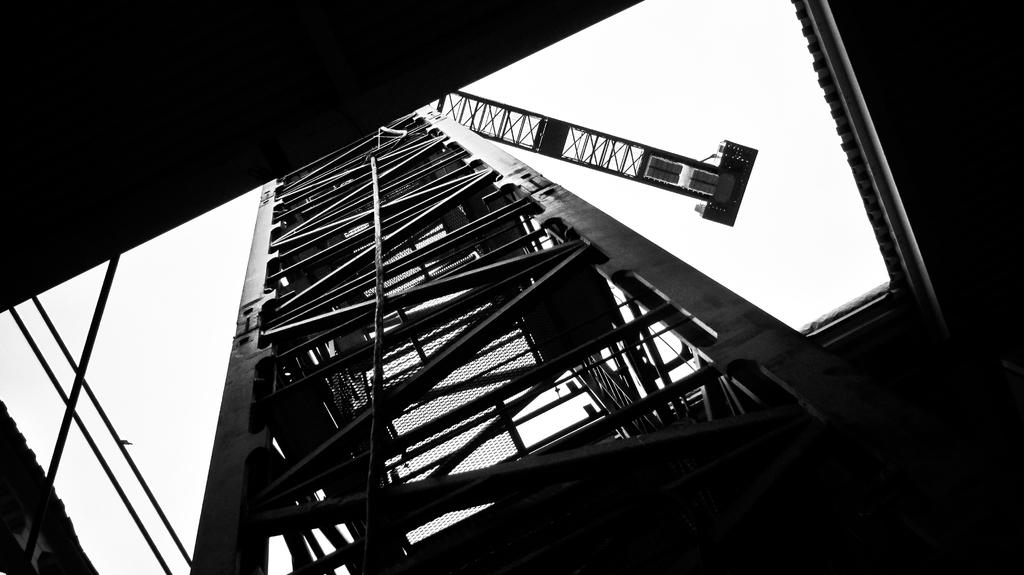What type of structure is present in the image? There is a building in the image. What material can be seen in the image besides the building? Metal rods are visible in the image. What part of the natural environment is visible in the image? The sky is visible in the image. How many rings are visible on the sheet in the image? There is no sheet or rings present in the image. 